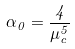Convert formula to latex. <formula><loc_0><loc_0><loc_500><loc_500>\alpha _ { 0 } = \frac { 4 } { \mu _ { c } ^ { 5 } }</formula> 